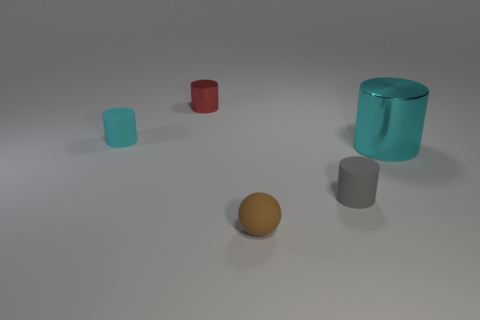Is the brown thing made of the same material as the cyan object on the left side of the gray rubber cylinder? Based on visual assessment, the brown object, which appears to be a sphere, seems to have a matte surface similar to that of the cyan-colored cube beside the gray cylinder. This could indicate they are made of similar materials, likely a type of matte plastic or painted wood, as they both lack the glossiness of the larger cyan cylinder which seems to be made of glass or transparent plastic. 